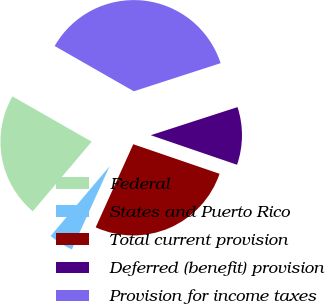Convert chart. <chart><loc_0><loc_0><loc_500><loc_500><pie_chart><fcel>Federal<fcel>States and Puerto Rico<fcel>Total current provision<fcel>Deferred (benefit) provision<fcel>Provision for income taxes<nl><fcel>22.1%<fcel>4.41%<fcel>26.51%<fcel>10.24%<fcel>36.75%<nl></chart> 